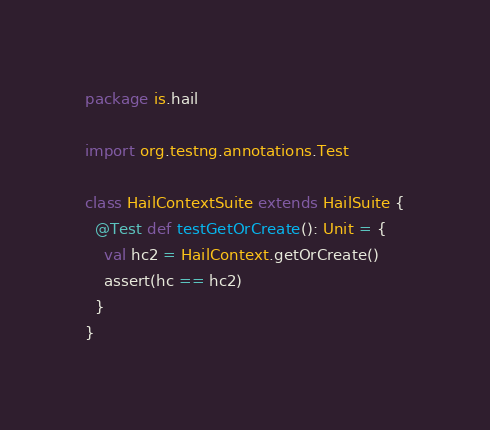Convert code to text. <code><loc_0><loc_0><loc_500><loc_500><_Scala_>package is.hail

import org.testng.annotations.Test

class HailContextSuite extends HailSuite {
  @Test def testGetOrCreate(): Unit = {
    val hc2 = HailContext.getOrCreate()
    assert(hc == hc2)
  }
}
</code> 